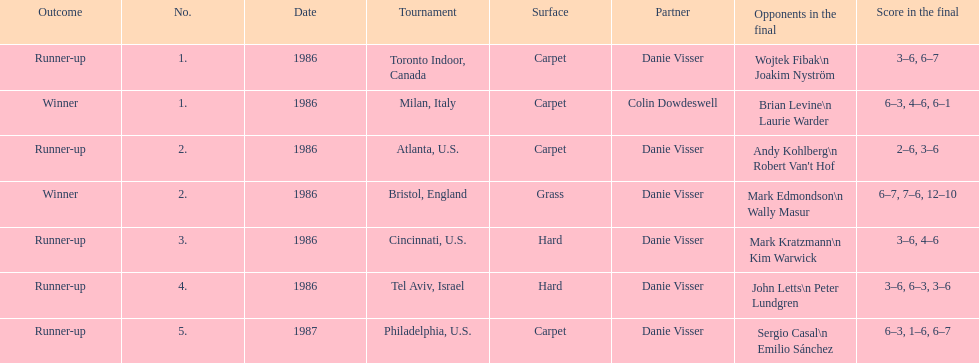What is the aggregate amount of grass and hard surfaces specified? 3. 